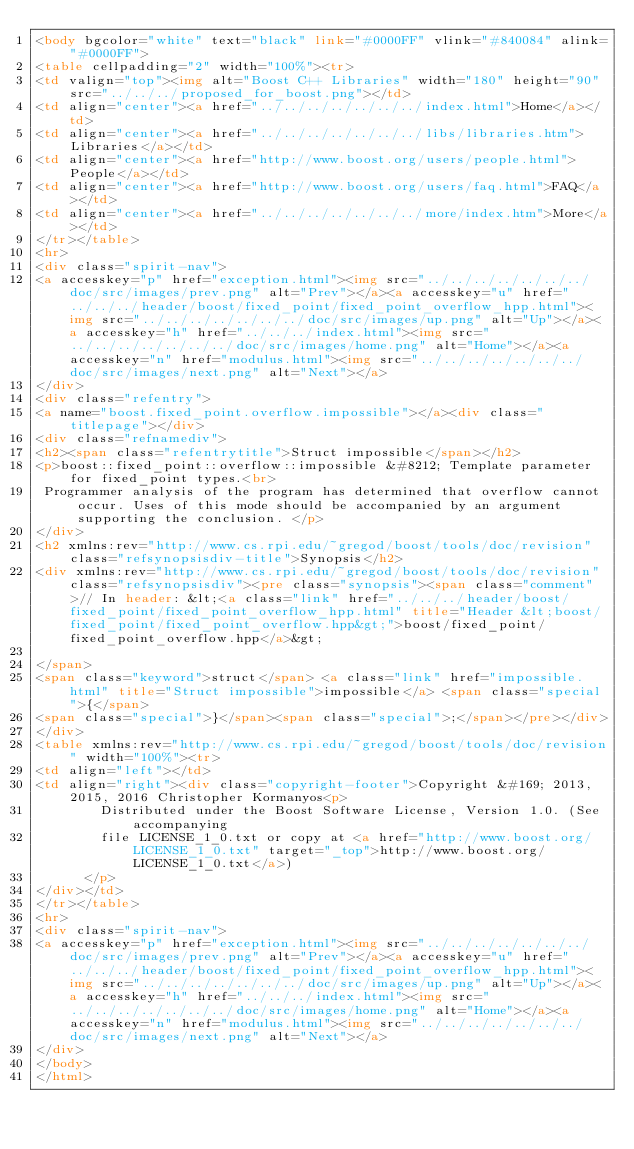Convert code to text. <code><loc_0><loc_0><loc_500><loc_500><_HTML_><body bgcolor="white" text="black" link="#0000FF" vlink="#840084" alink="#0000FF">
<table cellpadding="2" width="100%"><tr>
<td valign="top"><img alt="Boost C++ Libraries" width="180" height="90" src="../../../proposed_for_boost.png"></td>
<td align="center"><a href="../../../../../../../index.html">Home</a></td>
<td align="center"><a href="../../../../../../../libs/libraries.htm">Libraries</a></td>
<td align="center"><a href="http://www.boost.org/users/people.html">People</a></td>
<td align="center"><a href="http://www.boost.org/users/faq.html">FAQ</a></td>
<td align="center"><a href="../../../../../../../more/index.htm">More</a></td>
</tr></table>
<hr>
<div class="spirit-nav">
<a accesskey="p" href="exception.html"><img src="../../../../../../../doc/src/images/prev.png" alt="Prev"></a><a accesskey="u" href="../../../header/boost/fixed_point/fixed_point_overflow_hpp.html"><img src="../../../../../../../doc/src/images/up.png" alt="Up"></a><a accesskey="h" href="../../../index.html"><img src="../../../../../../../doc/src/images/home.png" alt="Home"></a><a accesskey="n" href="modulus.html"><img src="../../../../../../../doc/src/images/next.png" alt="Next"></a>
</div>
<div class="refentry">
<a name="boost.fixed_point.overflow.impossible"></a><div class="titlepage"></div>
<div class="refnamediv">
<h2><span class="refentrytitle">Struct impossible</span></h2>
<p>boost::fixed_point::overflow::impossible &#8212; Template parameter for fixed_point types.<br>
 Programmer analysis of the program has determined that overflow cannot occur. Uses of this mode should be accompanied by an argument supporting the conclusion. </p>
</div>
<h2 xmlns:rev="http://www.cs.rpi.edu/~gregod/boost/tools/doc/revision" class="refsynopsisdiv-title">Synopsis</h2>
<div xmlns:rev="http://www.cs.rpi.edu/~gregod/boost/tools/doc/revision" class="refsynopsisdiv"><pre class="synopsis"><span class="comment">// In header: &lt;<a class="link" href="../../../header/boost/fixed_point/fixed_point_overflow_hpp.html" title="Header &lt;boost/fixed_point/fixed_point_overflow.hpp&gt;">boost/fixed_point/fixed_point_overflow.hpp</a>&gt;

</span>
<span class="keyword">struct</span> <a class="link" href="impossible.html" title="Struct impossible">impossible</a> <span class="special">{</span>
<span class="special">}</span><span class="special">;</span></pre></div>
</div>
<table xmlns:rev="http://www.cs.rpi.edu/~gregod/boost/tools/doc/revision" width="100%"><tr>
<td align="left"></td>
<td align="right"><div class="copyright-footer">Copyright &#169; 2013, 2015, 2016 Christopher Kormanyos<p>
        Distributed under the Boost Software License, Version 1.0. (See accompanying
        file LICENSE_1_0.txt or copy at <a href="http://www.boost.org/LICENSE_1_0.txt" target="_top">http://www.boost.org/LICENSE_1_0.txt</a>)
      </p>
</div></td>
</tr></table>
<hr>
<div class="spirit-nav">
<a accesskey="p" href="exception.html"><img src="../../../../../../../doc/src/images/prev.png" alt="Prev"></a><a accesskey="u" href="../../../header/boost/fixed_point/fixed_point_overflow_hpp.html"><img src="../../../../../../../doc/src/images/up.png" alt="Up"></a><a accesskey="h" href="../../../index.html"><img src="../../../../../../../doc/src/images/home.png" alt="Home"></a><a accesskey="n" href="modulus.html"><img src="../../../../../../../doc/src/images/next.png" alt="Next"></a>
</div>
</body>
</html>
</code> 